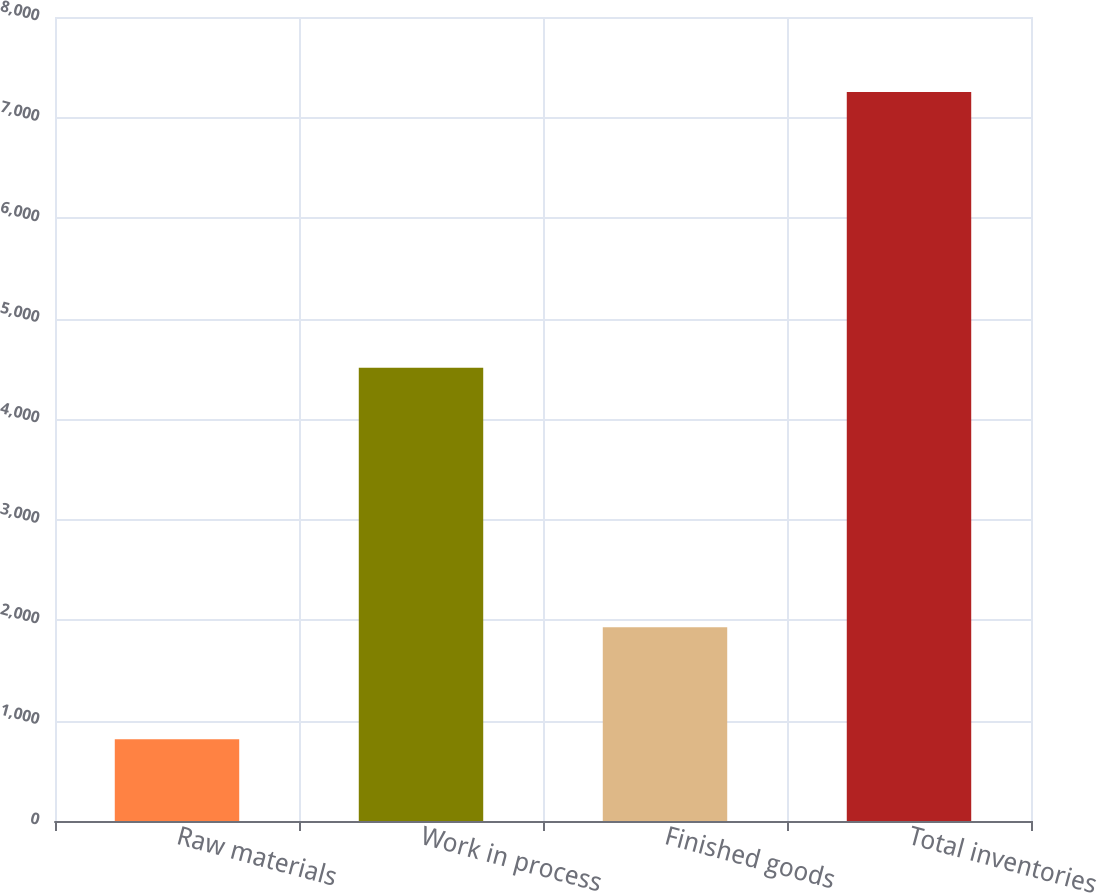Convert chart to OTSL. <chart><loc_0><loc_0><loc_500><loc_500><bar_chart><fcel>Raw materials<fcel>Work in process<fcel>Finished goods<fcel>Total inventories<nl><fcel>813<fcel>4511<fcel>1929<fcel>7253<nl></chart> 